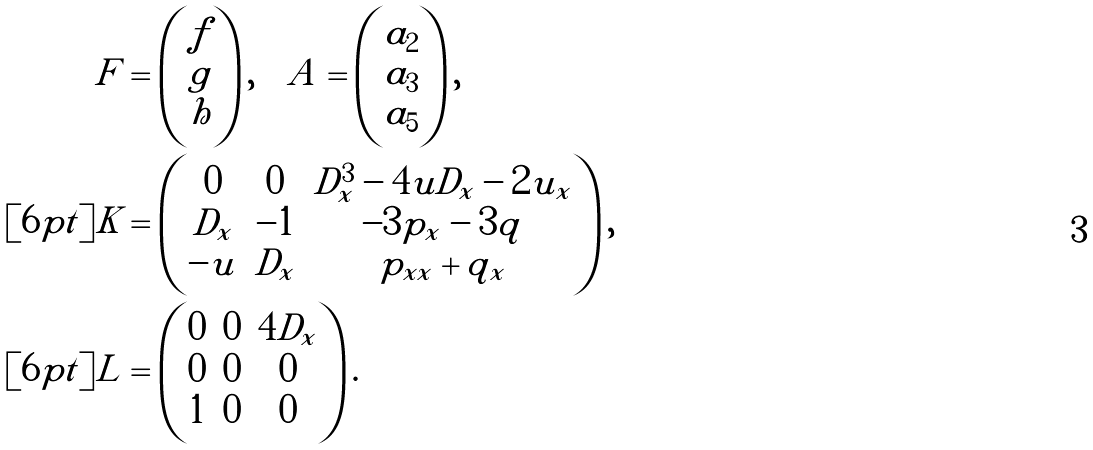Convert formula to latex. <formula><loc_0><loc_0><loc_500><loc_500>F & = \begin{pmatrix} f \\ g \\ h \end{pmatrix} , \quad A = \begin{pmatrix} a _ { 2 } \\ a _ { 3 } \\ a _ { 5 } \end{pmatrix} , \\ [ 6 p t ] K & = \begin{pmatrix} 0 & 0 & D _ { x } ^ { 3 } - 4 u D _ { x } - 2 u _ { x } \\ D _ { x } & - 1 & - 3 p _ { x } - 3 q \\ - u & D _ { x } & p _ { x x } + q _ { x } \end{pmatrix} , \\ [ 6 p t ] L & = \begin{pmatrix} 0 & 0 & 4 D _ { x } \\ 0 & 0 & 0 \\ 1 & 0 & 0 \end{pmatrix} .</formula> 